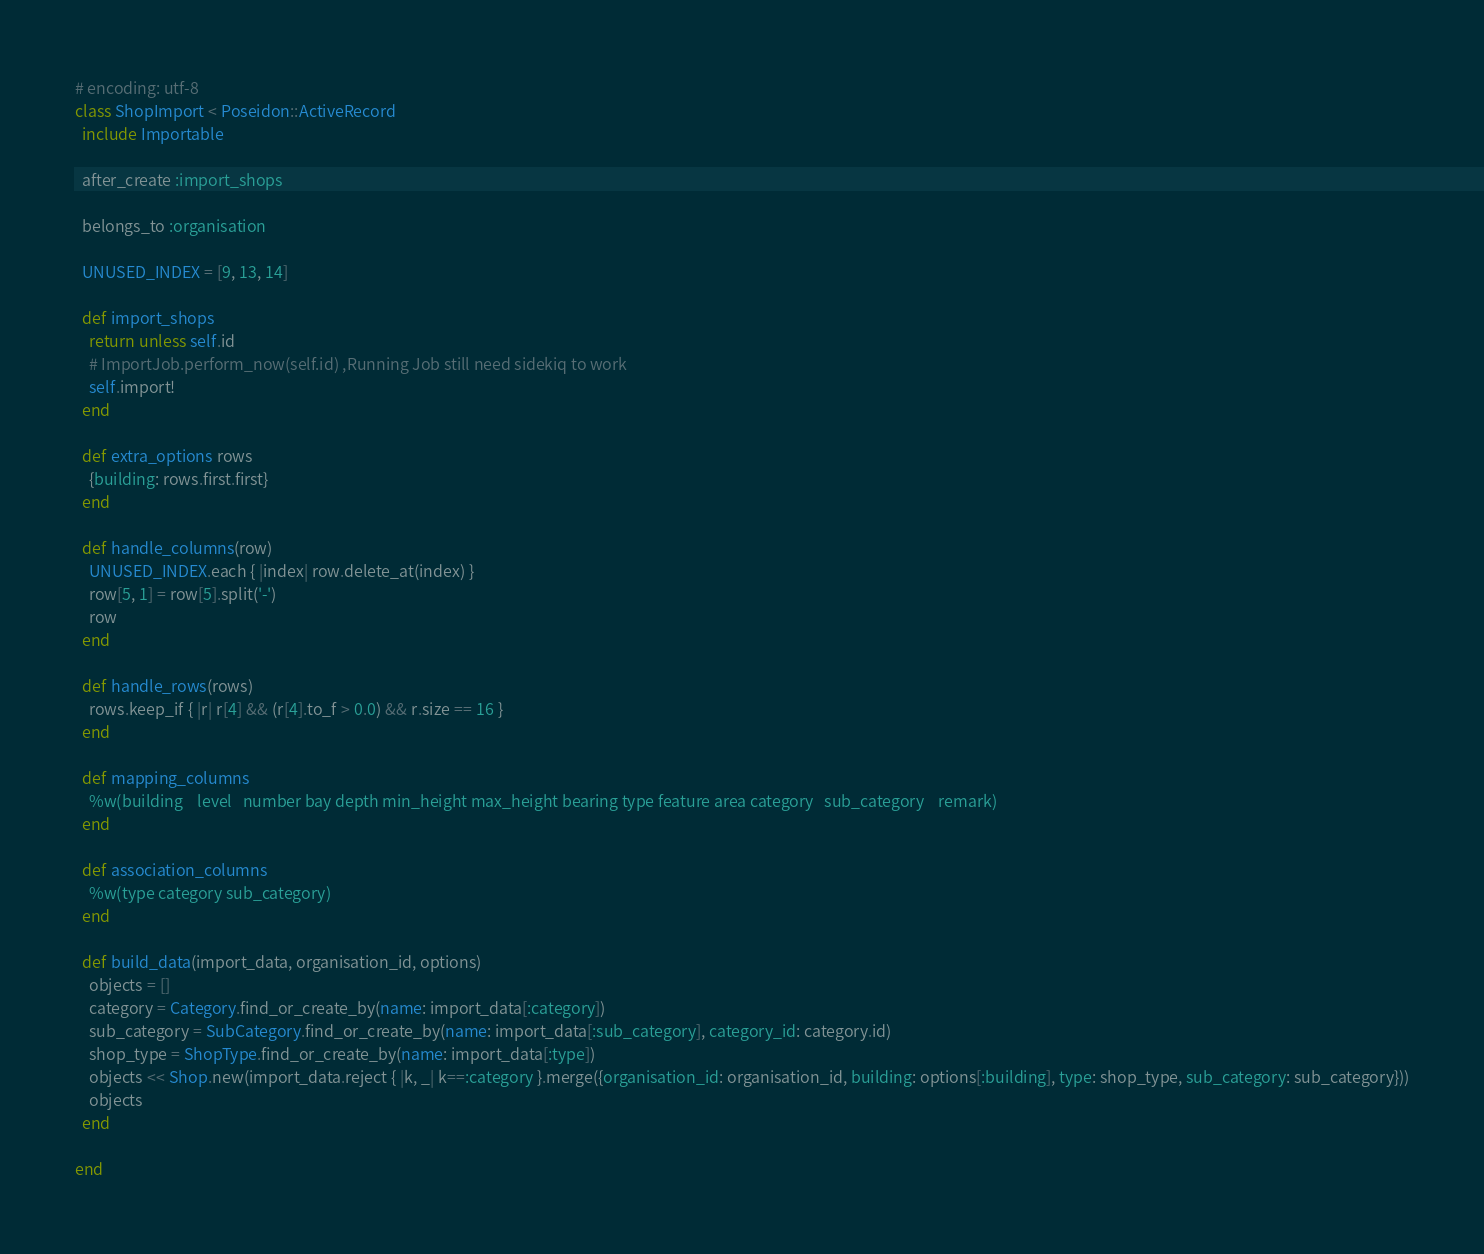<code> <loc_0><loc_0><loc_500><loc_500><_Ruby_># encoding: utf-8
class ShopImport < Poseidon::ActiveRecord
  include Importable

  after_create :import_shops

  belongs_to :organisation

  UNUSED_INDEX = [9, 13, 14]

  def import_shops
    return unless self.id
    # ImportJob.perform_now(self.id) ,Running Job still need sidekiq to work
    self.import!
  end

  def extra_options rows
    {building: rows.first.first}
  end

  def handle_columns(row)
    UNUSED_INDEX.each { |index| row.delete_at(index) }
    row[5, 1] = row[5].split('-')
    row
  end

  def handle_rows(rows)
    rows.keep_if { |r| r[4] && (r[4].to_f > 0.0) && r.size == 16 }
  end

  def mapping_columns
    %w(building	level	number bay depth min_height max_height bearing type feature	area category	sub_category	remark)
  end

  def association_columns
    %w(type category sub_category)
  end

  def build_data(import_data, organisation_id, options)
    objects = []
    category = Category.find_or_create_by(name: import_data[:category])
    sub_category = SubCategory.find_or_create_by(name: import_data[:sub_category], category_id: category.id)
    shop_type = ShopType.find_or_create_by(name: import_data[:type])
    objects << Shop.new(import_data.reject { |k, _| k==:category }.merge({organisation_id: organisation_id, building: options[:building], type: shop_type, sub_category: sub_category}))
    objects
  end

end
</code> 